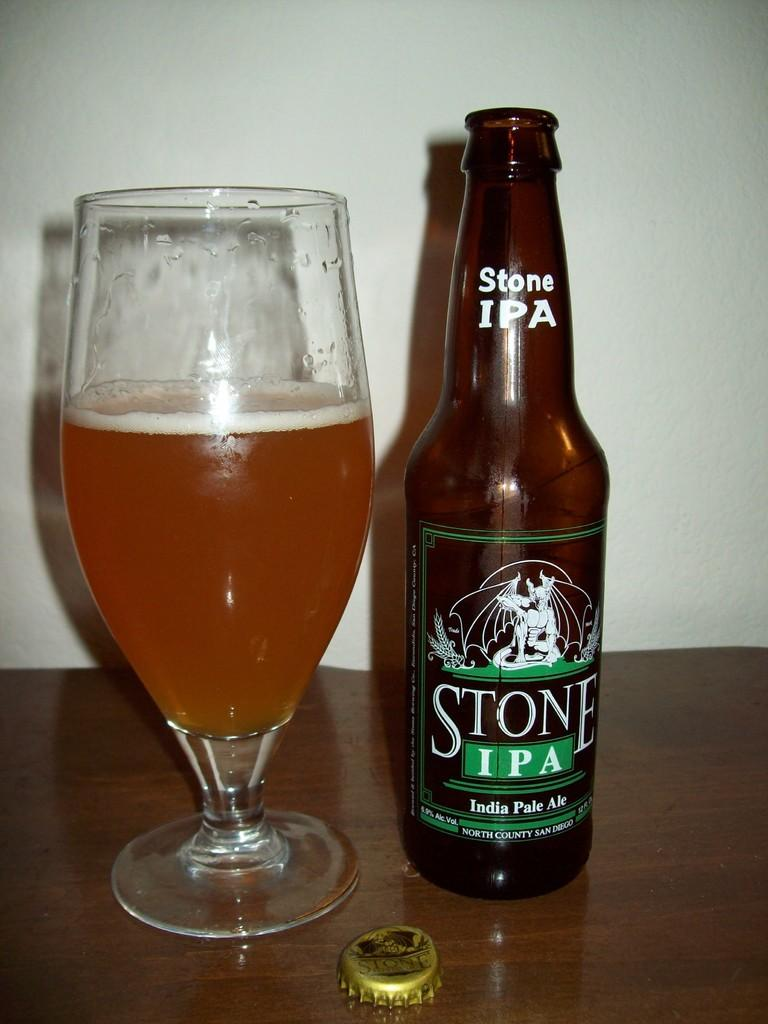What piece of furniture is visible in the image? There is a table in the image. What objects are on top of the table? A bottle and a wine glass are on top of the table. What color is the wall in the background of the image? The wall in the background of the image is white. What type of discussion is taking place in the image? There is no discussion taking place in the image; it only shows a table with a bottle and a wine glass on it, and a white wall in the background. 